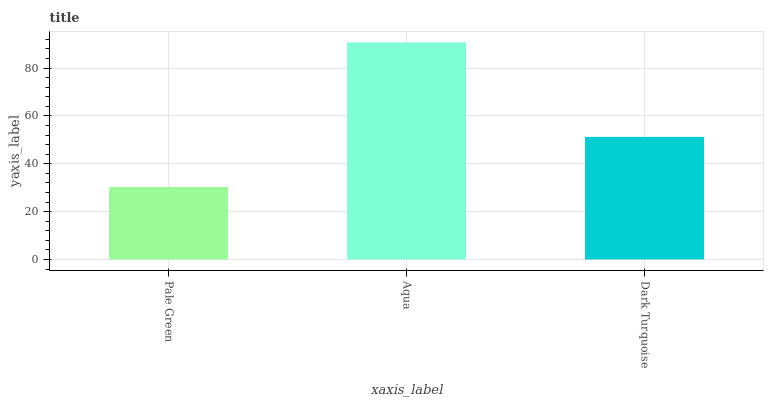Is Dark Turquoise the minimum?
Answer yes or no. No. Is Dark Turquoise the maximum?
Answer yes or no. No. Is Aqua greater than Dark Turquoise?
Answer yes or no. Yes. Is Dark Turquoise less than Aqua?
Answer yes or no. Yes. Is Dark Turquoise greater than Aqua?
Answer yes or no. No. Is Aqua less than Dark Turquoise?
Answer yes or no. No. Is Dark Turquoise the high median?
Answer yes or no. Yes. Is Dark Turquoise the low median?
Answer yes or no. Yes. Is Aqua the high median?
Answer yes or no. No. Is Aqua the low median?
Answer yes or no. No. 